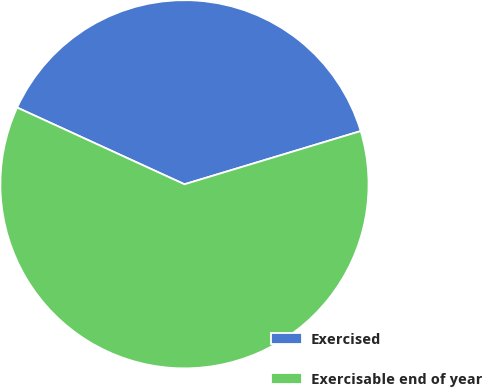<chart> <loc_0><loc_0><loc_500><loc_500><pie_chart><fcel>Exercised<fcel>Exercisable end of year<nl><fcel>38.49%<fcel>61.51%<nl></chart> 